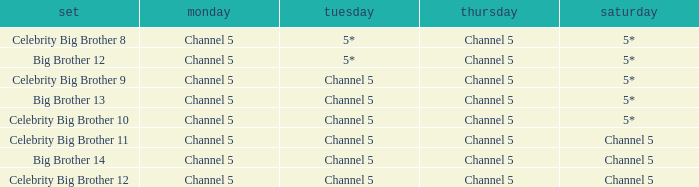Which Thursday does big brother 13 air? Channel 5. 